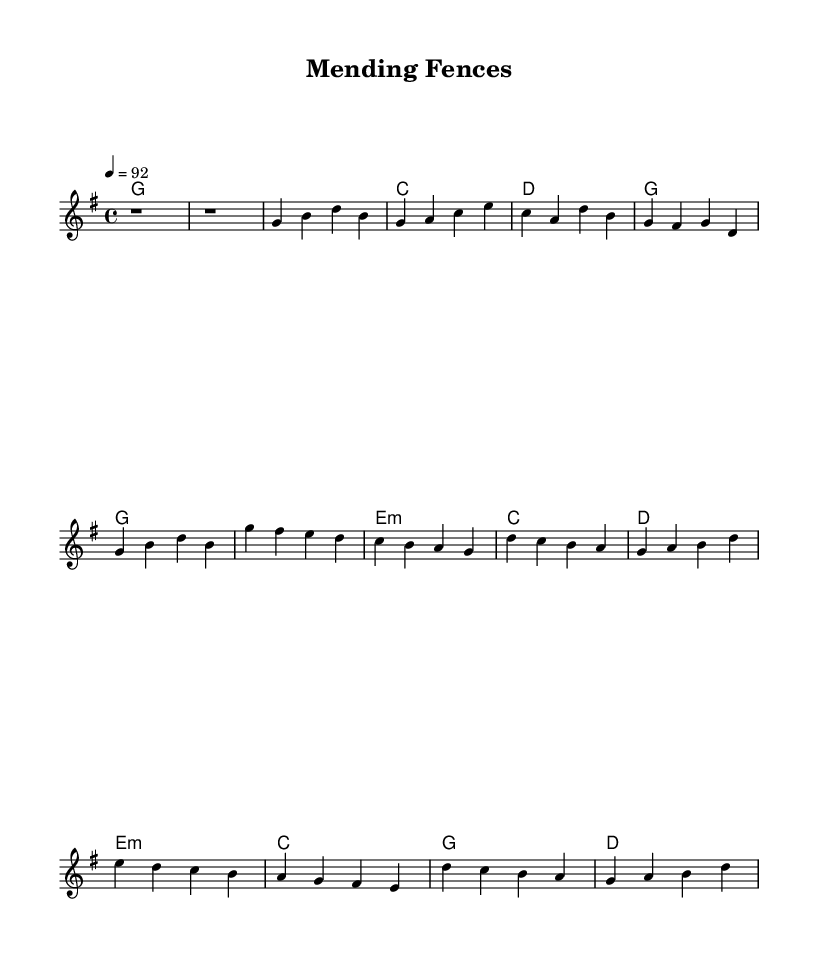What is the key signature of this music? The key signature is G major, indicated by one sharp (F#).
Answer: G major What is the time signature of the piece? The time signature is 4/4, which means there are four beats in a measure.
Answer: 4/4 What is the tempo marking for the piece? The tempo is indicated as 92 beats per minute, which provides a moderate pace for the performance.
Answer: 92 How many measures are in the verse section? The verse section consists of a total of 5 measures, as counted from the notation provided.
Answer: 5 measures What type of chord is used in the chorus? The chorus features an E minor chord, indicated by the "e:m" label in the harmonies.
Answer: E minor What is the emotional theme conveyed in the lyrics as suggested by the title? The title "Mending Fences" suggests themes of reconciliation and healing relationships, a common motif in country rock music focusing on personal growth.
Answer: Reconciliation Which musical element indicates a shift to a reflective mood in the piece? The bridge section, marked by different harmonies and a change in melody, introduces a reflective element contrasting with the verses and chorus.
Answer: Bridge section 